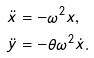Convert formula to latex. <formula><loc_0><loc_0><loc_500><loc_500>\ddot { x } & = - \omega ^ { 2 } x , \\ \ddot { y } & = - \theta \omega ^ { 2 } \dot { x } .</formula> 